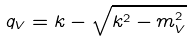<formula> <loc_0><loc_0><loc_500><loc_500>q _ { V } = k - \sqrt { k ^ { 2 } - m _ { V } ^ { 2 } }</formula> 